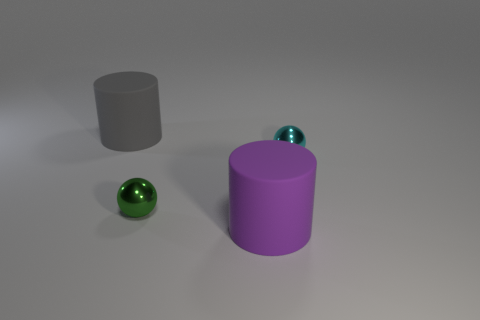There is a tiny object left of the shiny thing to the right of the green object; what is it made of?
Your response must be concise. Metal. There is a purple rubber thing that is the same size as the gray matte cylinder; what shape is it?
Offer a terse response. Cylinder. Is the number of cyan metallic balls less than the number of big cylinders?
Provide a succinct answer. Yes. There is a big object to the left of the purple rubber cylinder; are there any small green shiny things behind it?
Offer a terse response. No. What shape is the thing that is the same material as the gray cylinder?
Offer a terse response. Cylinder. There is another object that is the same shape as the big gray object; what material is it?
Give a very brief answer. Rubber. What number of other objects are the same size as the gray cylinder?
Provide a short and direct response. 1. There is a big rubber object in front of the gray object; is its shape the same as the large gray matte object?
Offer a very short reply. Yes. How many other things are there of the same shape as the purple matte thing?
Provide a succinct answer. 1. There is a tiny thing behind the small green ball; what is its shape?
Make the answer very short. Sphere. 